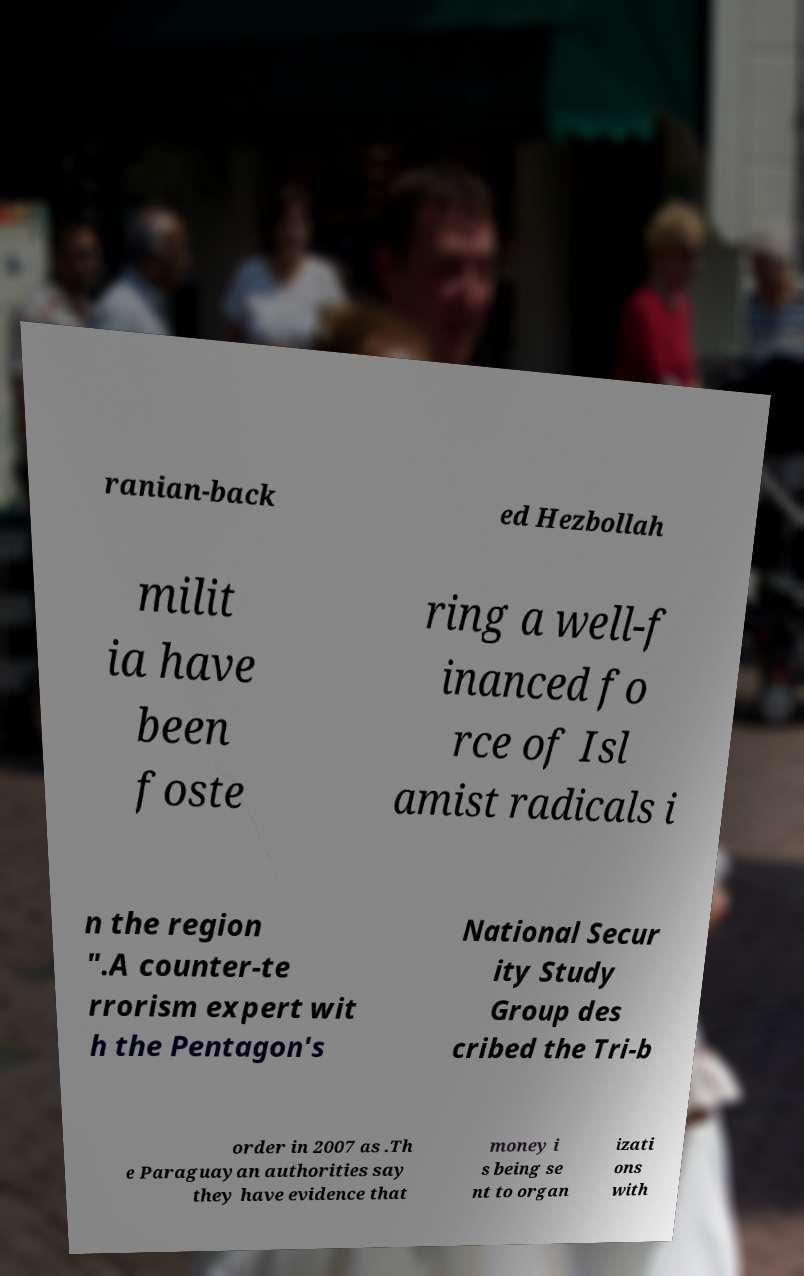Could you assist in decoding the text presented in this image and type it out clearly? ranian-back ed Hezbollah milit ia have been foste ring a well-f inanced fo rce of Isl amist radicals i n the region ".A counter-te rrorism expert wit h the Pentagon's National Secur ity Study Group des cribed the Tri-b order in 2007 as .Th e Paraguayan authorities say they have evidence that money i s being se nt to organ izati ons with 